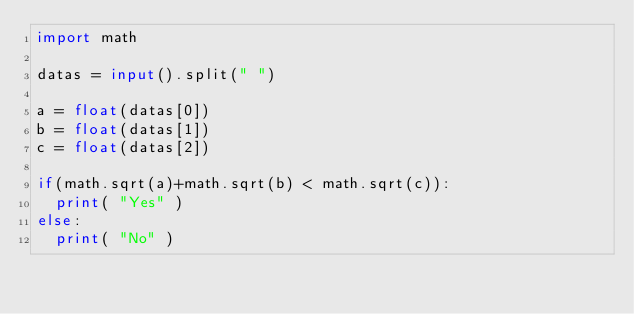Convert code to text. <code><loc_0><loc_0><loc_500><loc_500><_Python_>import math
 
datas = input().split(" ")
 
a = float(datas[0])
b = float(datas[1])
c = float(datas[2])
 
if(math.sqrt(a)+math.sqrt(b) < math.sqrt(c)):
  print( "Yes" )
else:
  print( "No" )</code> 